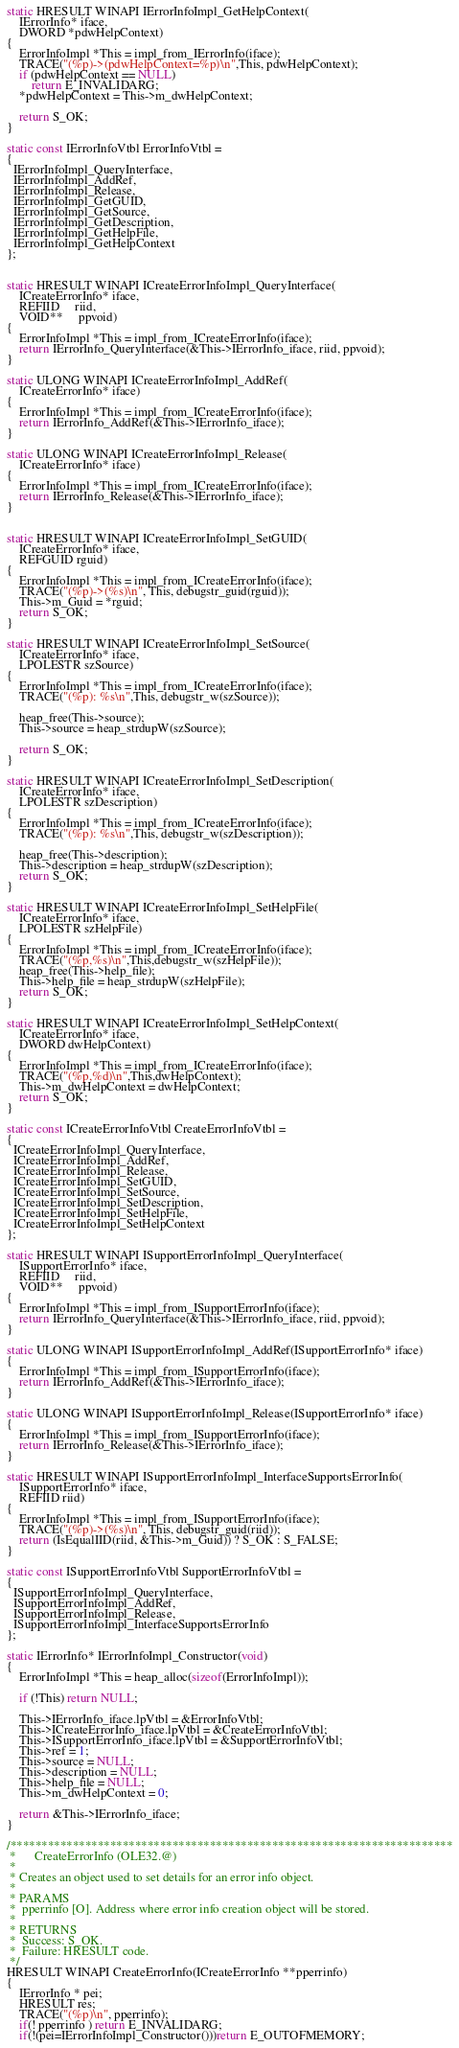<code> <loc_0><loc_0><loc_500><loc_500><_C_>static HRESULT WINAPI IErrorInfoImpl_GetHelpContext(
	IErrorInfo* iface,
	DWORD *pdwHelpContext)
{
	ErrorInfoImpl *This = impl_from_IErrorInfo(iface);
	TRACE("(%p)->(pdwHelpContext=%p)\n",This, pdwHelpContext);
	if (pdwHelpContext == NULL)
	    return E_INVALIDARG;
	*pdwHelpContext = This->m_dwHelpContext;

	return S_OK;
}

static const IErrorInfoVtbl ErrorInfoVtbl =
{
  IErrorInfoImpl_QueryInterface,
  IErrorInfoImpl_AddRef,
  IErrorInfoImpl_Release,
  IErrorInfoImpl_GetGUID,
  IErrorInfoImpl_GetSource,
  IErrorInfoImpl_GetDescription,
  IErrorInfoImpl_GetHelpFile,
  IErrorInfoImpl_GetHelpContext
};


static HRESULT WINAPI ICreateErrorInfoImpl_QueryInterface(
	ICreateErrorInfo* iface,
	REFIID     riid,
	VOID**     ppvoid)
{
    ErrorInfoImpl *This = impl_from_ICreateErrorInfo(iface);
    return IErrorInfo_QueryInterface(&This->IErrorInfo_iface, riid, ppvoid);
}

static ULONG WINAPI ICreateErrorInfoImpl_AddRef(
 	ICreateErrorInfo* iface)
{
    ErrorInfoImpl *This = impl_from_ICreateErrorInfo(iface);
    return IErrorInfo_AddRef(&This->IErrorInfo_iface);
}

static ULONG WINAPI ICreateErrorInfoImpl_Release(
	ICreateErrorInfo* iface)
{
    ErrorInfoImpl *This = impl_from_ICreateErrorInfo(iface);
    return IErrorInfo_Release(&This->IErrorInfo_iface);
}


static HRESULT WINAPI ICreateErrorInfoImpl_SetGUID(
	ICreateErrorInfo* iface,
	REFGUID rguid)
{
	ErrorInfoImpl *This = impl_from_ICreateErrorInfo(iface);
	TRACE("(%p)->(%s)\n", This, debugstr_guid(rguid));
	This->m_Guid = *rguid;
	return S_OK;
}

static HRESULT WINAPI ICreateErrorInfoImpl_SetSource(
	ICreateErrorInfo* iface,
	LPOLESTR szSource)
{
	ErrorInfoImpl *This = impl_from_ICreateErrorInfo(iface);
	TRACE("(%p): %s\n",This, debugstr_w(szSource));

	heap_free(This->source);
	This->source = heap_strdupW(szSource);

	return S_OK;
}

static HRESULT WINAPI ICreateErrorInfoImpl_SetDescription(
	ICreateErrorInfo* iface,
	LPOLESTR szDescription)
{
	ErrorInfoImpl *This = impl_from_ICreateErrorInfo(iface);
	TRACE("(%p): %s\n",This, debugstr_w(szDescription));

	heap_free(This->description);
	This->description = heap_strdupW(szDescription);
	return S_OK;
}

static HRESULT WINAPI ICreateErrorInfoImpl_SetHelpFile(
	ICreateErrorInfo* iface,
	LPOLESTR szHelpFile)
{
	ErrorInfoImpl *This = impl_from_ICreateErrorInfo(iface);
	TRACE("(%p,%s)\n",This,debugstr_w(szHelpFile));
	heap_free(This->help_file);
	This->help_file = heap_strdupW(szHelpFile);
	return S_OK;
}

static HRESULT WINAPI ICreateErrorInfoImpl_SetHelpContext(
	ICreateErrorInfo* iface,
 	DWORD dwHelpContext)
{
	ErrorInfoImpl *This = impl_from_ICreateErrorInfo(iface);
	TRACE("(%p,%d)\n",This,dwHelpContext);
	This->m_dwHelpContext = dwHelpContext;
	return S_OK;
}

static const ICreateErrorInfoVtbl CreateErrorInfoVtbl =
{
  ICreateErrorInfoImpl_QueryInterface,
  ICreateErrorInfoImpl_AddRef,
  ICreateErrorInfoImpl_Release,
  ICreateErrorInfoImpl_SetGUID,
  ICreateErrorInfoImpl_SetSource,
  ICreateErrorInfoImpl_SetDescription,
  ICreateErrorInfoImpl_SetHelpFile,
  ICreateErrorInfoImpl_SetHelpContext
};

static HRESULT WINAPI ISupportErrorInfoImpl_QueryInterface(
	ISupportErrorInfo* iface,
	REFIID     riid,
	VOID**     ppvoid)
{
    ErrorInfoImpl *This = impl_from_ISupportErrorInfo(iface);
    return IErrorInfo_QueryInterface(&This->IErrorInfo_iface, riid, ppvoid);
}

static ULONG WINAPI ISupportErrorInfoImpl_AddRef(ISupportErrorInfo* iface)
{
    ErrorInfoImpl *This = impl_from_ISupportErrorInfo(iface);
    return IErrorInfo_AddRef(&This->IErrorInfo_iface);
}

static ULONG WINAPI ISupportErrorInfoImpl_Release(ISupportErrorInfo* iface)
{
    ErrorInfoImpl *This = impl_from_ISupportErrorInfo(iface);
    return IErrorInfo_Release(&This->IErrorInfo_iface);
}

static HRESULT WINAPI ISupportErrorInfoImpl_InterfaceSupportsErrorInfo(
	ISupportErrorInfo* iface,
	REFIID riid)
{
	ErrorInfoImpl *This = impl_from_ISupportErrorInfo(iface);
	TRACE("(%p)->(%s)\n", This, debugstr_guid(riid));
	return (IsEqualIID(riid, &This->m_Guid)) ? S_OK : S_FALSE;
}

static const ISupportErrorInfoVtbl SupportErrorInfoVtbl =
{
  ISupportErrorInfoImpl_QueryInterface,
  ISupportErrorInfoImpl_AddRef,
  ISupportErrorInfoImpl_Release,
  ISupportErrorInfoImpl_InterfaceSupportsErrorInfo
};

static IErrorInfo* IErrorInfoImpl_Constructor(void)
{
    ErrorInfoImpl *This = heap_alloc(sizeof(ErrorInfoImpl));

    if (!This) return NULL;

    This->IErrorInfo_iface.lpVtbl = &ErrorInfoVtbl;
    This->ICreateErrorInfo_iface.lpVtbl = &CreateErrorInfoVtbl;
    This->ISupportErrorInfo_iface.lpVtbl = &SupportErrorInfoVtbl;
    This->ref = 1;
    This->source = NULL;
    This->description = NULL;
    This->help_file = NULL;
    This->m_dwHelpContext = 0;

    return &This->IErrorInfo_iface;
}

/***********************************************************************
 *		CreateErrorInfo (OLE32.@)
 *
 * Creates an object used to set details for an error info object.
 *
 * PARAMS
 *  pperrinfo [O]. Address where error info creation object will be stored.
 *
 * RETURNS
 *  Success: S_OK.
 *  Failure: HRESULT code.
 */
HRESULT WINAPI CreateErrorInfo(ICreateErrorInfo **pperrinfo)
{
	IErrorInfo * pei;
	HRESULT res;
	TRACE("(%p)\n", pperrinfo);
	if(! pperrinfo ) return E_INVALIDARG;
	if(!(pei=IErrorInfoImpl_Constructor()))return E_OUTOFMEMORY;
</code> 